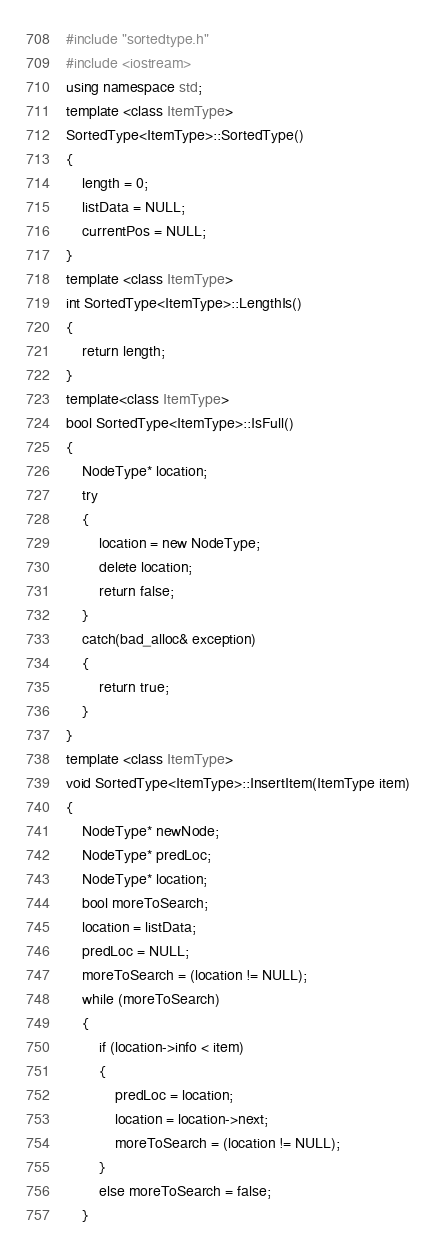Convert code to text. <code><loc_0><loc_0><loc_500><loc_500><_C++_>#include "sortedtype.h"
#include <iostream>
using namespace std;
template <class ItemType>
SortedType<ItemType>::SortedType()
{
    length = 0;
    listData = NULL;
    currentPos = NULL;
}
template <class ItemType>
int SortedType<ItemType>::LengthIs()
{
    return length;
}
template<class ItemType>
bool SortedType<ItemType>::IsFull()
{
    NodeType* location;
    try
    {
        location = new NodeType;
        delete location;
        return false;
    }
    catch(bad_alloc& exception)
    {
        return true;
    }
}
template <class ItemType>
void SortedType<ItemType>::InsertItem(ItemType item)
{
    NodeType* newNode;
    NodeType* predLoc;
    NodeType* location;
    bool moreToSearch;
    location = listData;
    predLoc = NULL;
    moreToSearch = (location != NULL);
    while (moreToSearch)
    {
        if (location->info < item)
        {
            predLoc = location;
            location = location->next;
            moreToSearch = (location != NULL);
        }
        else moreToSearch = false;
    }</code> 